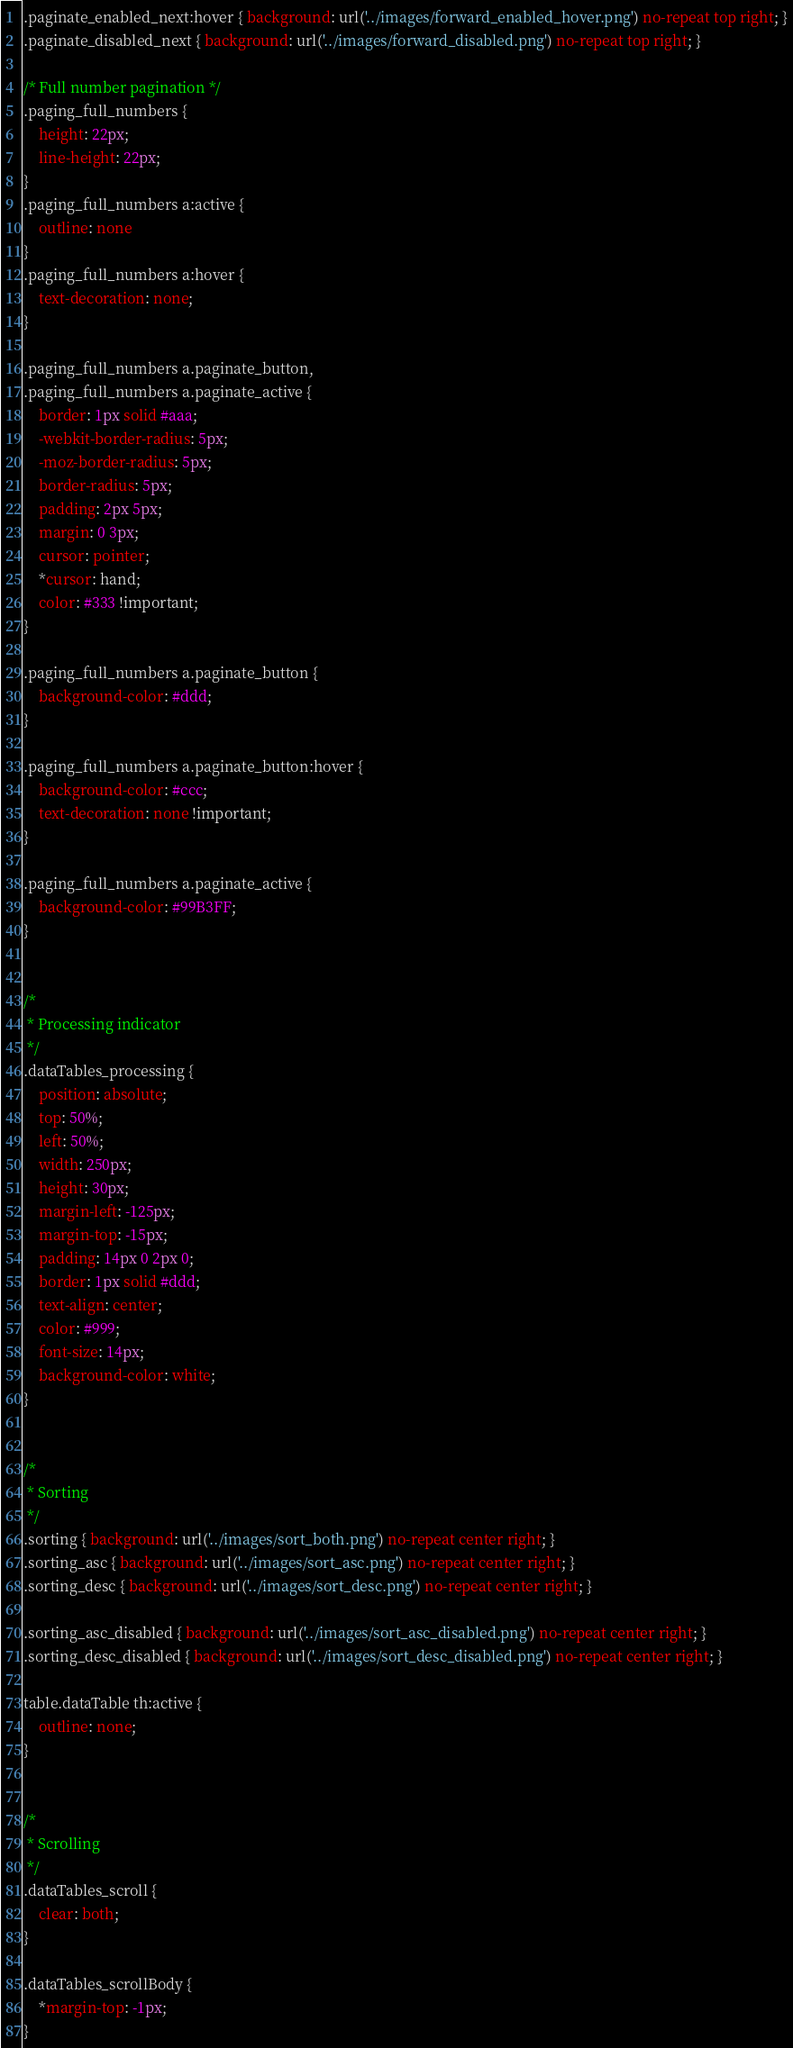Convert code to text. <code><loc_0><loc_0><loc_500><loc_500><_CSS_>.paginate_enabled_next:hover { background: url('../images/forward_enabled_hover.png') no-repeat top right; }
.paginate_disabled_next { background: url('../images/forward_disabled.png') no-repeat top right; }

/* Full number pagination */
.paging_full_numbers {
	height: 22px;
	line-height: 22px;
}
.paging_full_numbers a:active {
	outline: none
}
.paging_full_numbers a:hover {
	text-decoration: none;
}

.paging_full_numbers a.paginate_button,
.paging_full_numbers a.paginate_active {
	border: 1px solid #aaa;
	-webkit-border-radius: 5px;
	-moz-border-radius: 5px;
	border-radius: 5px;
	padding: 2px 5px;
	margin: 0 3px;
	cursor: pointer;
	*cursor: hand;
	color: #333 !important;
}

.paging_full_numbers a.paginate_button {
	background-color: #ddd;
}

.paging_full_numbers a.paginate_button:hover {
	background-color: #ccc;
	text-decoration: none !important;
}

.paging_full_numbers a.paginate_active {
	background-color: #99B3FF;
}


/*
 * Processing indicator
 */
.dataTables_processing {
	position: absolute;
	top: 50%;
	left: 50%;
	width: 250px;
	height: 30px;
	margin-left: -125px;
	margin-top: -15px;
	padding: 14px 0 2px 0;
	border: 1px solid #ddd;
	text-align: center;
	color: #999;
	font-size: 14px;
	background-color: white;
}


/*
 * Sorting
 */
.sorting { background: url('../images/sort_both.png') no-repeat center right; }
.sorting_asc { background: url('../images/sort_asc.png') no-repeat center right; }
.sorting_desc { background: url('../images/sort_desc.png') no-repeat center right; }

.sorting_asc_disabled { background: url('../images/sort_asc_disabled.png') no-repeat center right; }
.sorting_desc_disabled { background: url('../images/sort_desc_disabled.png') no-repeat center right; }
 
table.dataTable th:active {
	outline: none;
}


/*
 * Scrolling
 */
.dataTables_scroll {
	clear: both;
}

.dataTables_scrollBody {
	*margin-top: -1px;
}
</code> 